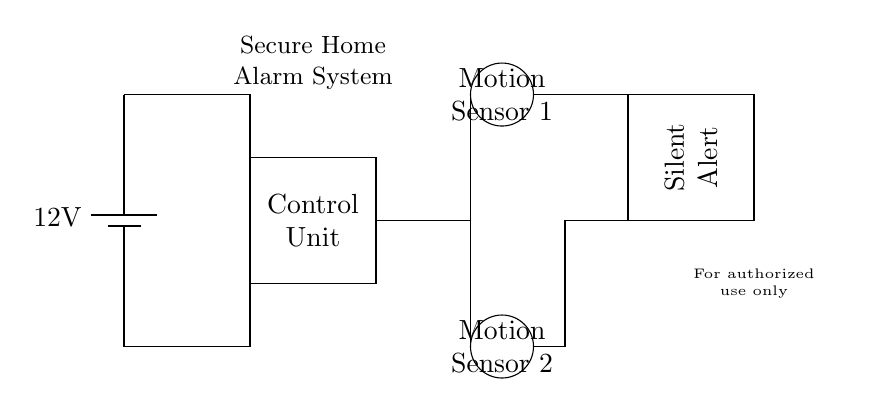What is the voltage of the power supply? The circuit diagram specifies a 12V battery as the power supply. This can be found at the top left corner where the battery symbol is drawn.
Answer: 12V How many motion sensors are in the circuit? The circuit diagram shows two circular shapes labeled as Motion Sensor 1 and Motion Sensor 2, indicating the presence of two motion sensors in total.
Answer: 2 What does the control unit do? The control unit is represented by a rectangle labeled "Control Unit" in the circuit diagram. It serves as the main hub for processing the signals from the motion sensors.
Answer: Processing Which component is responsible for silent alerts? The rectangle labeled "Silent Alert" is designed to ensure that alerts are sent without sound, indicating its functional role in the circuit.
Answer: Silent Alert What type of circuit is this designed for? The components and their arrangement in the diagram indicate that this is a security system circuit, which is specifically designed for home alarms.
Answer: Security system How are the motion sensors powered? The motion sensors are connected to the control unit, which in turn is powered by the 12V battery. The connections from the battery to the control unit and then to the sensors outline this power flow.
Answer: Through the control unit 